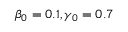<formula> <loc_0><loc_0><loc_500><loc_500>\beta _ { 0 } = 0 . 1 , \gamma _ { 0 } = 0 . 7</formula> 